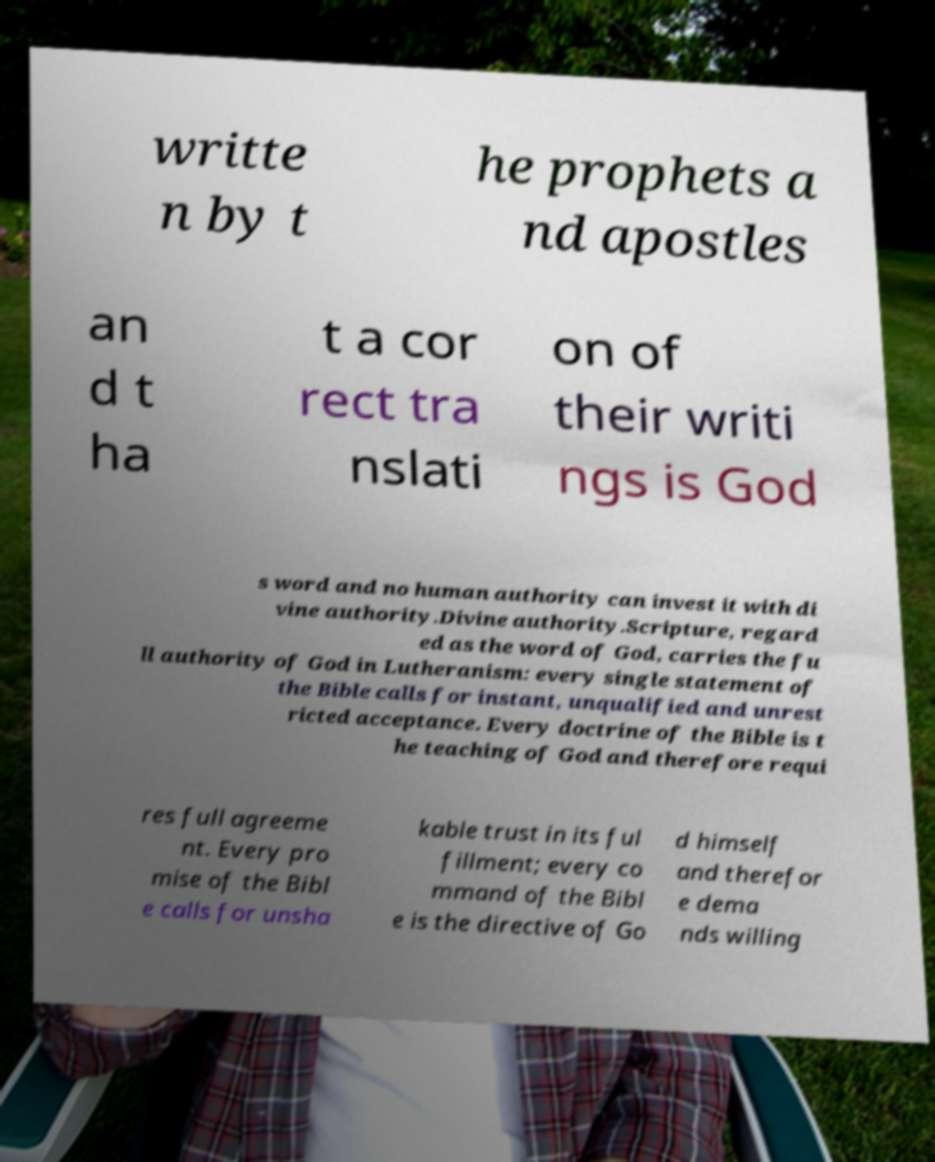There's text embedded in this image that I need extracted. Can you transcribe it verbatim? writte n by t he prophets a nd apostles an d t ha t a cor rect tra nslati on of their writi ngs is God s word and no human authority can invest it with di vine authority.Divine authority.Scripture, regard ed as the word of God, carries the fu ll authority of God in Lutheranism: every single statement of the Bible calls for instant, unqualified and unrest ricted acceptance. Every doctrine of the Bible is t he teaching of God and therefore requi res full agreeme nt. Every pro mise of the Bibl e calls for unsha kable trust in its ful fillment; every co mmand of the Bibl e is the directive of Go d himself and therefor e dema nds willing 